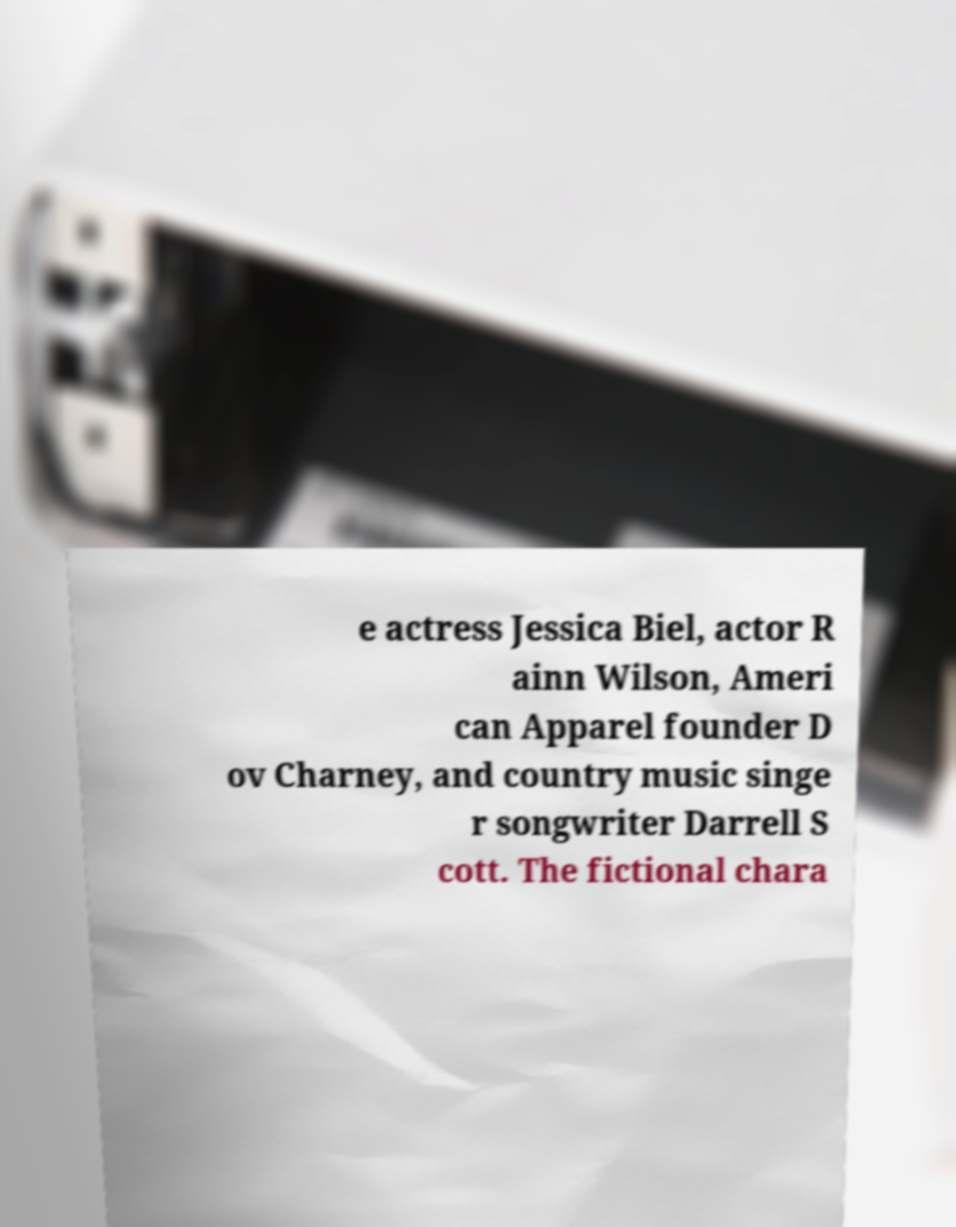Can you accurately transcribe the text from the provided image for me? e actress Jessica Biel, actor R ainn Wilson, Ameri can Apparel founder D ov Charney, and country music singe r songwriter Darrell S cott. The fictional chara 